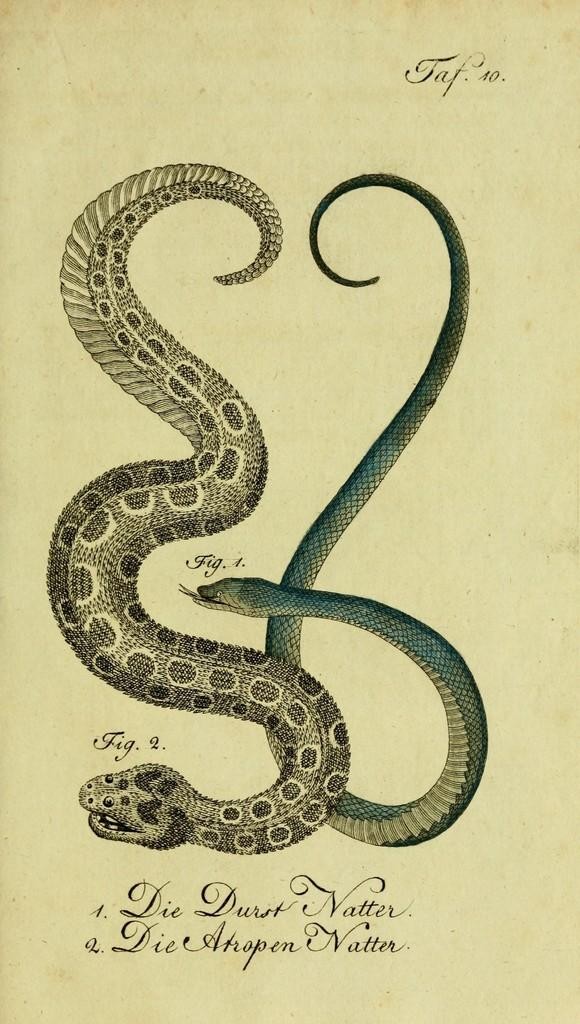What is depicted in the drawing in the image? There is a drawing of snakes in the image. What else can be seen on the paper in the image? There is text on the paper in the image. What type of glue is used to attach the snakes to the paper in the image? There is no glue present in the image, as the snakes are part of a drawing and not physically attached to the paper. 